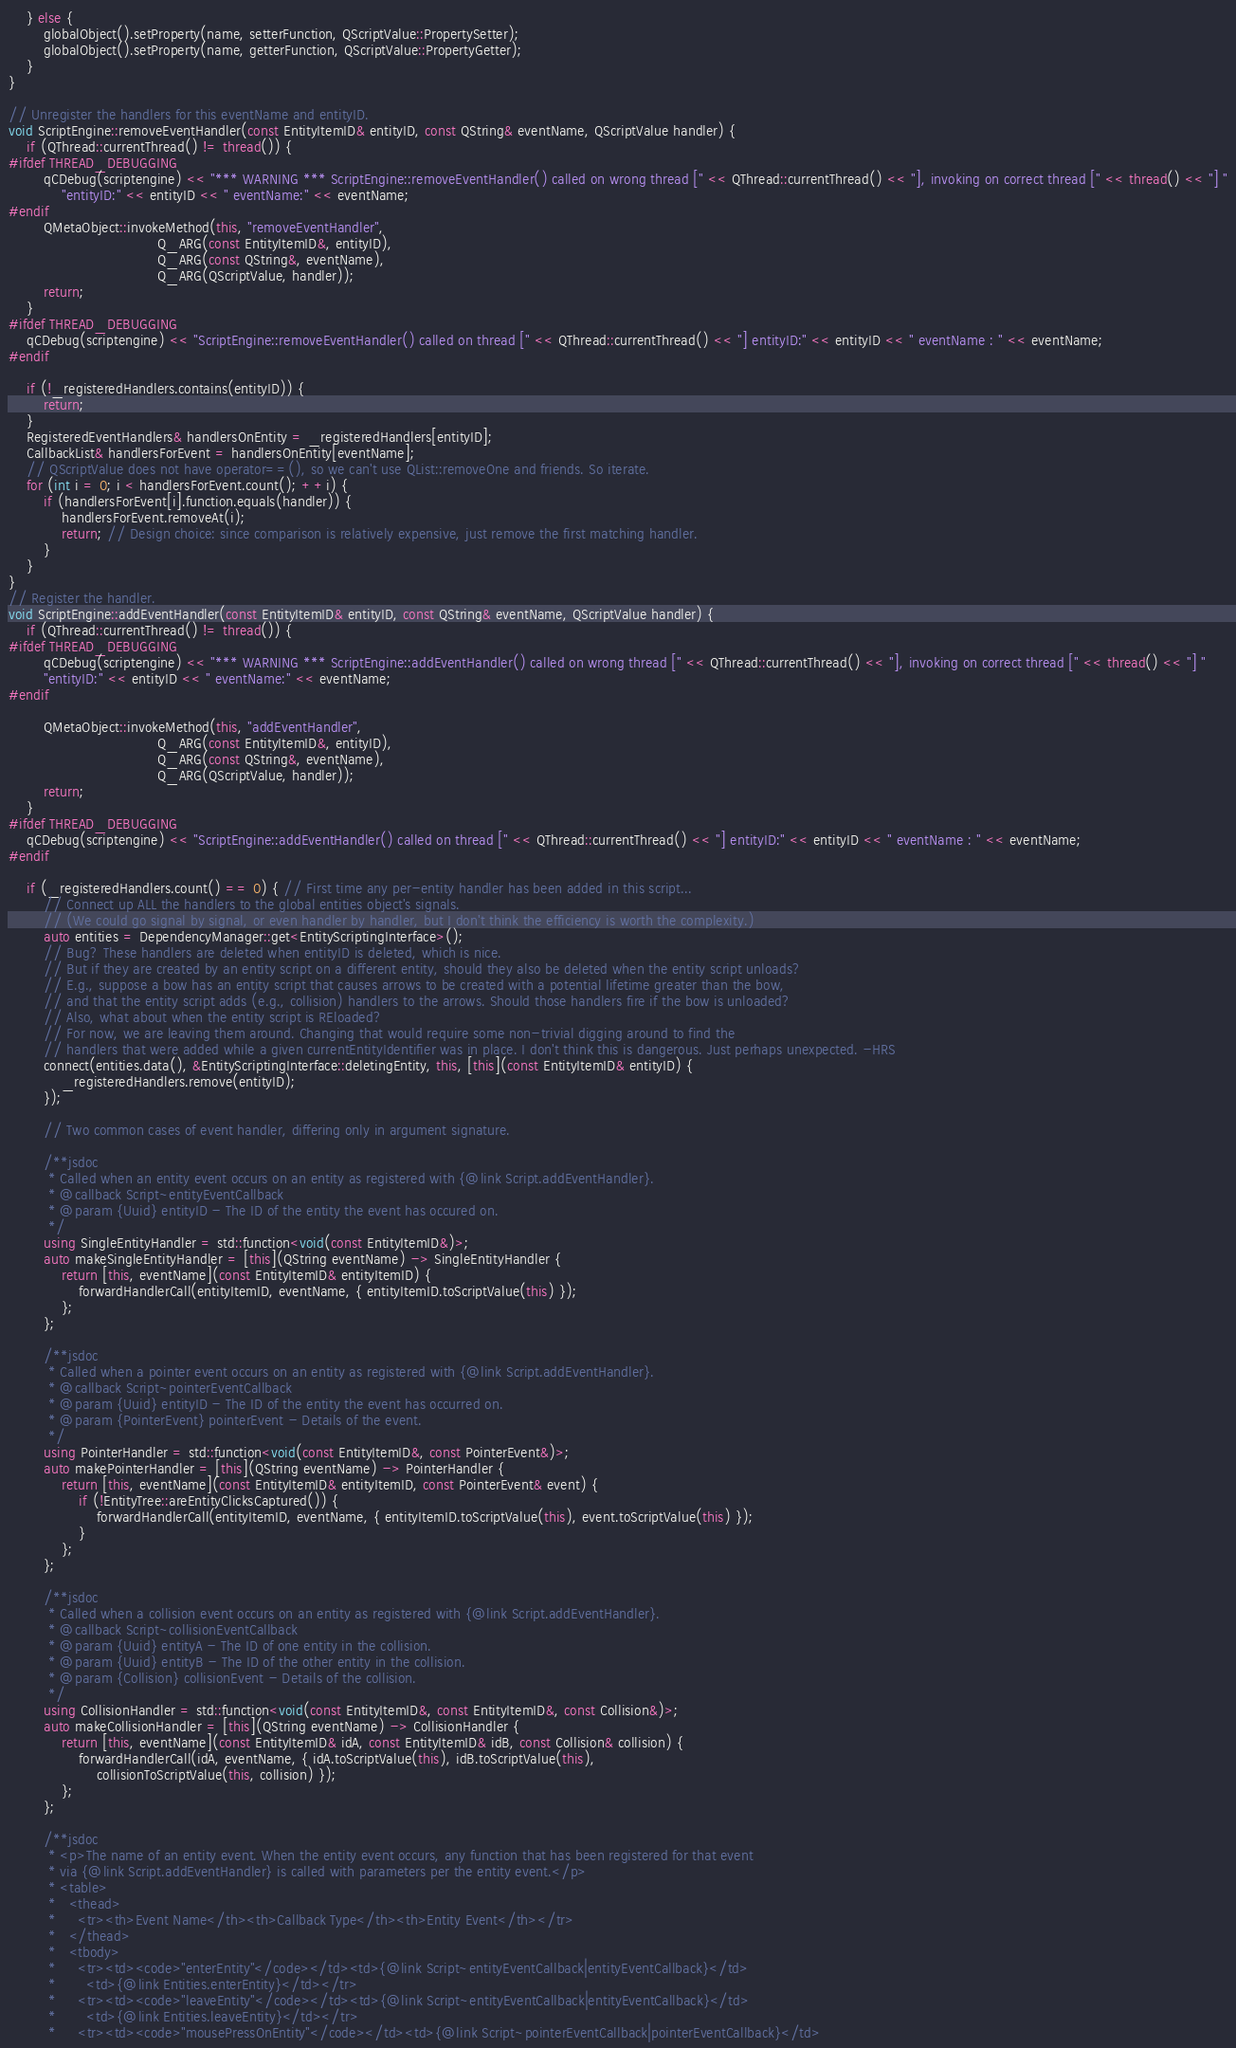Convert code to text. <code><loc_0><loc_0><loc_500><loc_500><_C++_>    } else {
        globalObject().setProperty(name, setterFunction, QScriptValue::PropertySetter);
        globalObject().setProperty(name, getterFunction, QScriptValue::PropertyGetter);
    }
}

// Unregister the handlers for this eventName and entityID.
void ScriptEngine::removeEventHandler(const EntityItemID& entityID, const QString& eventName, QScriptValue handler) {
    if (QThread::currentThread() != thread()) {
#ifdef THREAD_DEBUGGING
        qCDebug(scriptengine) << "*** WARNING *** ScriptEngine::removeEventHandler() called on wrong thread [" << QThread::currentThread() << "], invoking on correct thread [" << thread() << "] "
            "entityID:" << entityID << " eventName:" << eventName;
#endif
        QMetaObject::invokeMethod(this, "removeEventHandler",
                                  Q_ARG(const EntityItemID&, entityID),
                                  Q_ARG(const QString&, eventName),
                                  Q_ARG(QScriptValue, handler));
        return;
    }
#ifdef THREAD_DEBUGGING
    qCDebug(scriptengine) << "ScriptEngine::removeEventHandler() called on thread [" << QThread::currentThread() << "] entityID:" << entityID << " eventName : " << eventName;
#endif

    if (!_registeredHandlers.contains(entityID)) {
        return;
    }
    RegisteredEventHandlers& handlersOnEntity = _registeredHandlers[entityID];
    CallbackList& handlersForEvent = handlersOnEntity[eventName];
    // QScriptValue does not have operator==(), so we can't use QList::removeOne and friends. So iterate.
    for (int i = 0; i < handlersForEvent.count(); ++i) {
        if (handlersForEvent[i].function.equals(handler)) {
            handlersForEvent.removeAt(i);
            return; // Design choice: since comparison is relatively expensive, just remove the first matching handler.
        }
    }
}
// Register the handler.
void ScriptEngine::addEventHandler(const EntityItemID& entityID, const QString& eventName, QScriptValue handler) {
    if (QThread::currentThread() != thread()) {
#ifdef THREAD_DEBUGGING
        qCDebug(scriptengine) << "*** WARNING *** ScriptEngine::addEventHandler() called on wrong thread [" << QThread::currentThread() << "], invoking on correct thread [" << thread() << "] "
        "entityID:" << entityID << " eventName:" << eventName;
#endif

        QMetaObject::invokeMethod(this, "addEventHandler",
                                  Q_ARG(const EntityItemID&, entityID),
                                  Q_ARG(const QString&, eventName),
                                  Q_ARG(QScriptValue, handler));
        return;
    }
#ifdef THREAD_DEBUGGING
    qCDebug(scriptengine) << "ScriptEngine::addEventHandler() called on thread [" << QThread::currentThread() << "] entityID:" << entityID << " eventName : " << eventName;
#endif

    if (_registeredHandlers.count() == 0) { // First time any per-entity handler has been added in this script...
        // Connect up ALL the handlers to the global entities object's signals.
        // (We could go signal by signal, or even handler by handler, but I don't think the efficiency is worth the complexity.)
        auto entities = DependencyManager::get<EntityScriptingInterface>();
        // Bug? These handlers are deleted when entityID is deleted, which is nice.
        // But if they are created by an entity script on a different entity, should they also be deleted when the entity script unloads?
        // E.g., suppose a bow has an entity script that causes arrows to be created with a potential lifetime greater than the bow,
        // and that the entity script adds (e.g., collision) handlers to the arrows. Should those handlers fire if the bow is unloaded?
        // Also, what about when the entity script is REloaded?
        // For now, we are leaving them around. Changing that would require some non-trivial digging around to find the
        // handlers that were added while a given currentEntityIdentifier was in place. I don't think this is dangerous. Just perhaps unexpected. -HRS
        connect(entities.data(), &EntityScriptingInterface::deletingEntity, this, [this](const EntityItemID& entityID) {
            _registeredHandlers.remove(entityID);
        });

        // Two common cases of event handler, differing only in argument signature.

        /**jsdoc
         * Called when an entity event occurs on an entity as registered with {@link Script.addEventHandler}.
         * @callback Script~entityEventCallback
         * @param {Uuid} entityID - The ID of the entity the event has occured on.
         */
        using SingleEntityHandler = std::function<void(const EntityItemID&)>;
        auto makeSingleEntityHandler = [this](QString eventName) -> SingleEntityHandler {
            return [this, eventName](const EntityItemID& entityItemID) {
                forwardHandlerCall(entityItemID, eventName, { entityItemID.toScriptValue(this) });
            };
        };

        /**jsdoc
         * Called when a pointer event occurs on an entity as registered with {@link Script.addEventHandler}.
         * @callback Script~pointerEventCallback
         * @param {Uuid} entityID - The ID of the entity the event has occurred on.
         * @param {PointerEvent} pointerEvent - Details of the event.
         */
        using PointerHandler = std::function<void(const EntityItemID&, const PointerEvent&)>;
        auto makePointerHandler = [this](QString eventName) -> PointerHandler {
            return [this, eventName](const EntityItemID& entityItemID, const PointerEvent& event) {
                if (!EntityTree::areEntityClicksCaptured()) {
                    forwardHandlerCall(entityItemID, eventName, { entityItemID.toScriptValue(this), event.toScriptValue(this) });
                }
            };
        };

        /**jsdoc
         * Called when a collision event occurs on an entity as registered with {@link Script.addEventHandler}.
         * @callback Script~collisionEventCallback
         * @param {Uuid} entityA - The ID of one entity in the collision.
         * @param {Uuid} entityB - The ID of the other entity in the collision.
         * @param {Collision} collisionEvent - Details of the collision.
         */
        using CollisionHandler = std::function<void(const EntityItemID&, const EntityItemID&, const Collision&)>;
        auto makeCollisionHandler = [this](QString eventName) -> CollisionHandler {
            return [this, eventName](const EntityItemID& idA, const EntityItemID& idB, const Collision& collision) {
                forwardHandlerCall(idA, eventName, { idA.toScriptValue(this), idB.toScriptValue(this),
                    collisionToScriptValue(this, collision) });
            };
        };

        /**jsdoc
         * <p>The name of an entity event. When the entity event occurs, any function that has been registered for that event 
         * via {@link Script.addEventHandler} is called with parameters per the entity event.</p>
         * <table>
         *   <thead>
         *     <tr><th>Event Name</th><th>Callback Type</th><th>Entity Event</th></tr>
         *   </thead>
         *   <tbody>
         *     <tr><td><code>"enterEntity"</code></td><td>{@link Script~entityEventCallback|entityEventCallback}</td>
         *       <td>{@link Entities.enterEntity}</td></tr>
         *     <tr><td><code>"leaveEntity"</code></td><td>{@link Script~entityEventCallback|entityEventCallback}</td>
         *       <td>{@link Entities.leaveEntity}</td></tr>
         *     <tr><td><code>"mousePressOnEntity"</code></td><td>{@link Script~pointerEventCallback|pointerEventCallback}</td></code> 